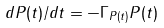Convert formula to latex. <formula><loc_0><loc_0><loc_500><loc_500>d P ( t ) / d t = - \Gamma _ { P ( t ) } P ( t )</formula> 